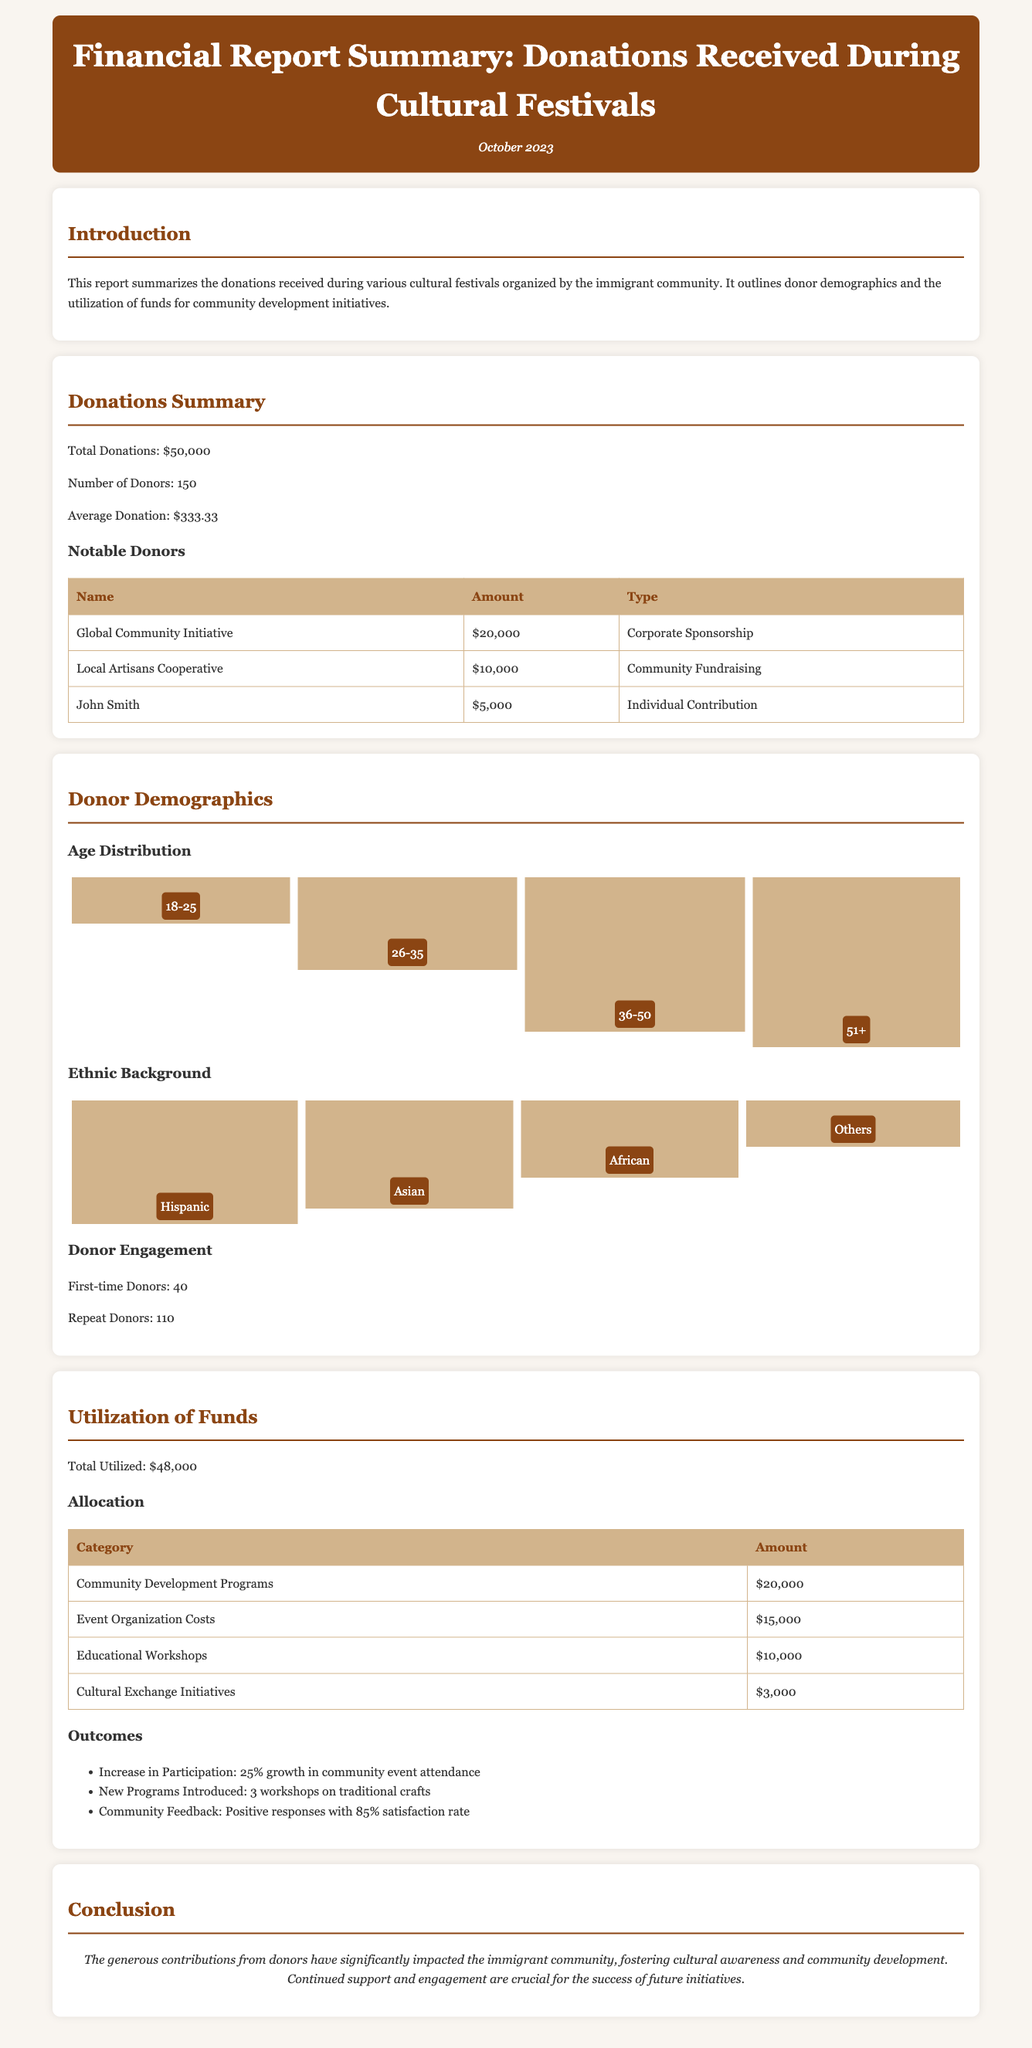What is the total amount of donations received? The total amount of donations received during the cultural festivals is specifically noted in the document.
Answer: $50,000 How many donors contributed during the festivals? The number of donors is explicitly stated in the report, indicating how many individuals or organizations made contributions.
Answer: 150 Who is the notable corporate sponsor? The name of the notable corporate sponsor is listed in the notable donors' section of the report.
Answer: Global Community Initiative What percentage increase was noted in community event attendance? The document provides outcomes related to community event engagement, including specific percentage growth.
Answer: 25% What was the total amount allocated to community development programs? The allocation of funds to different categories is provided, specifying the amount for community development.
Answer: $20,000 How many first-time donors were there? The document specifies the engagement of donors, including the number of first-time contributions.
Answer: 40 What is the satisfaction rate from community feedback? Feedback outcomes, including a satisfaction rate, are included in the report, showing community response.
Answer: 85% How much was utilized for educational workshops? The table detailing fund allocation includes the specific amount dedicated to educational workshops.
Answer: $10,000 